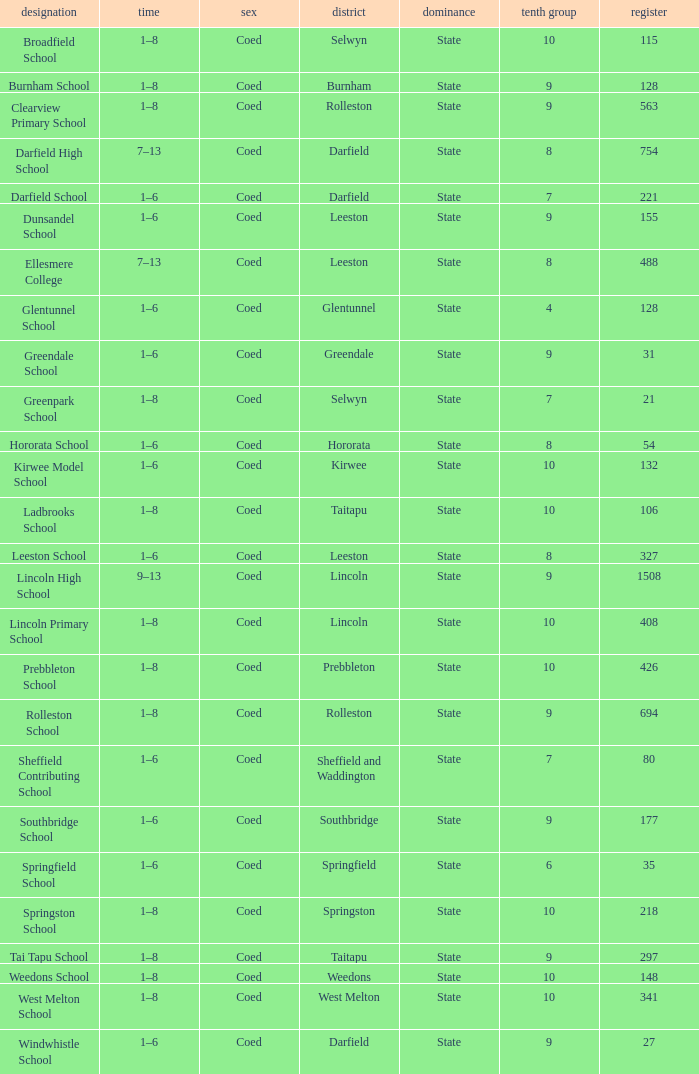Which name has a Roll larger than 297, and Years of 7–13? Darfield High School, Ellesmere College. 